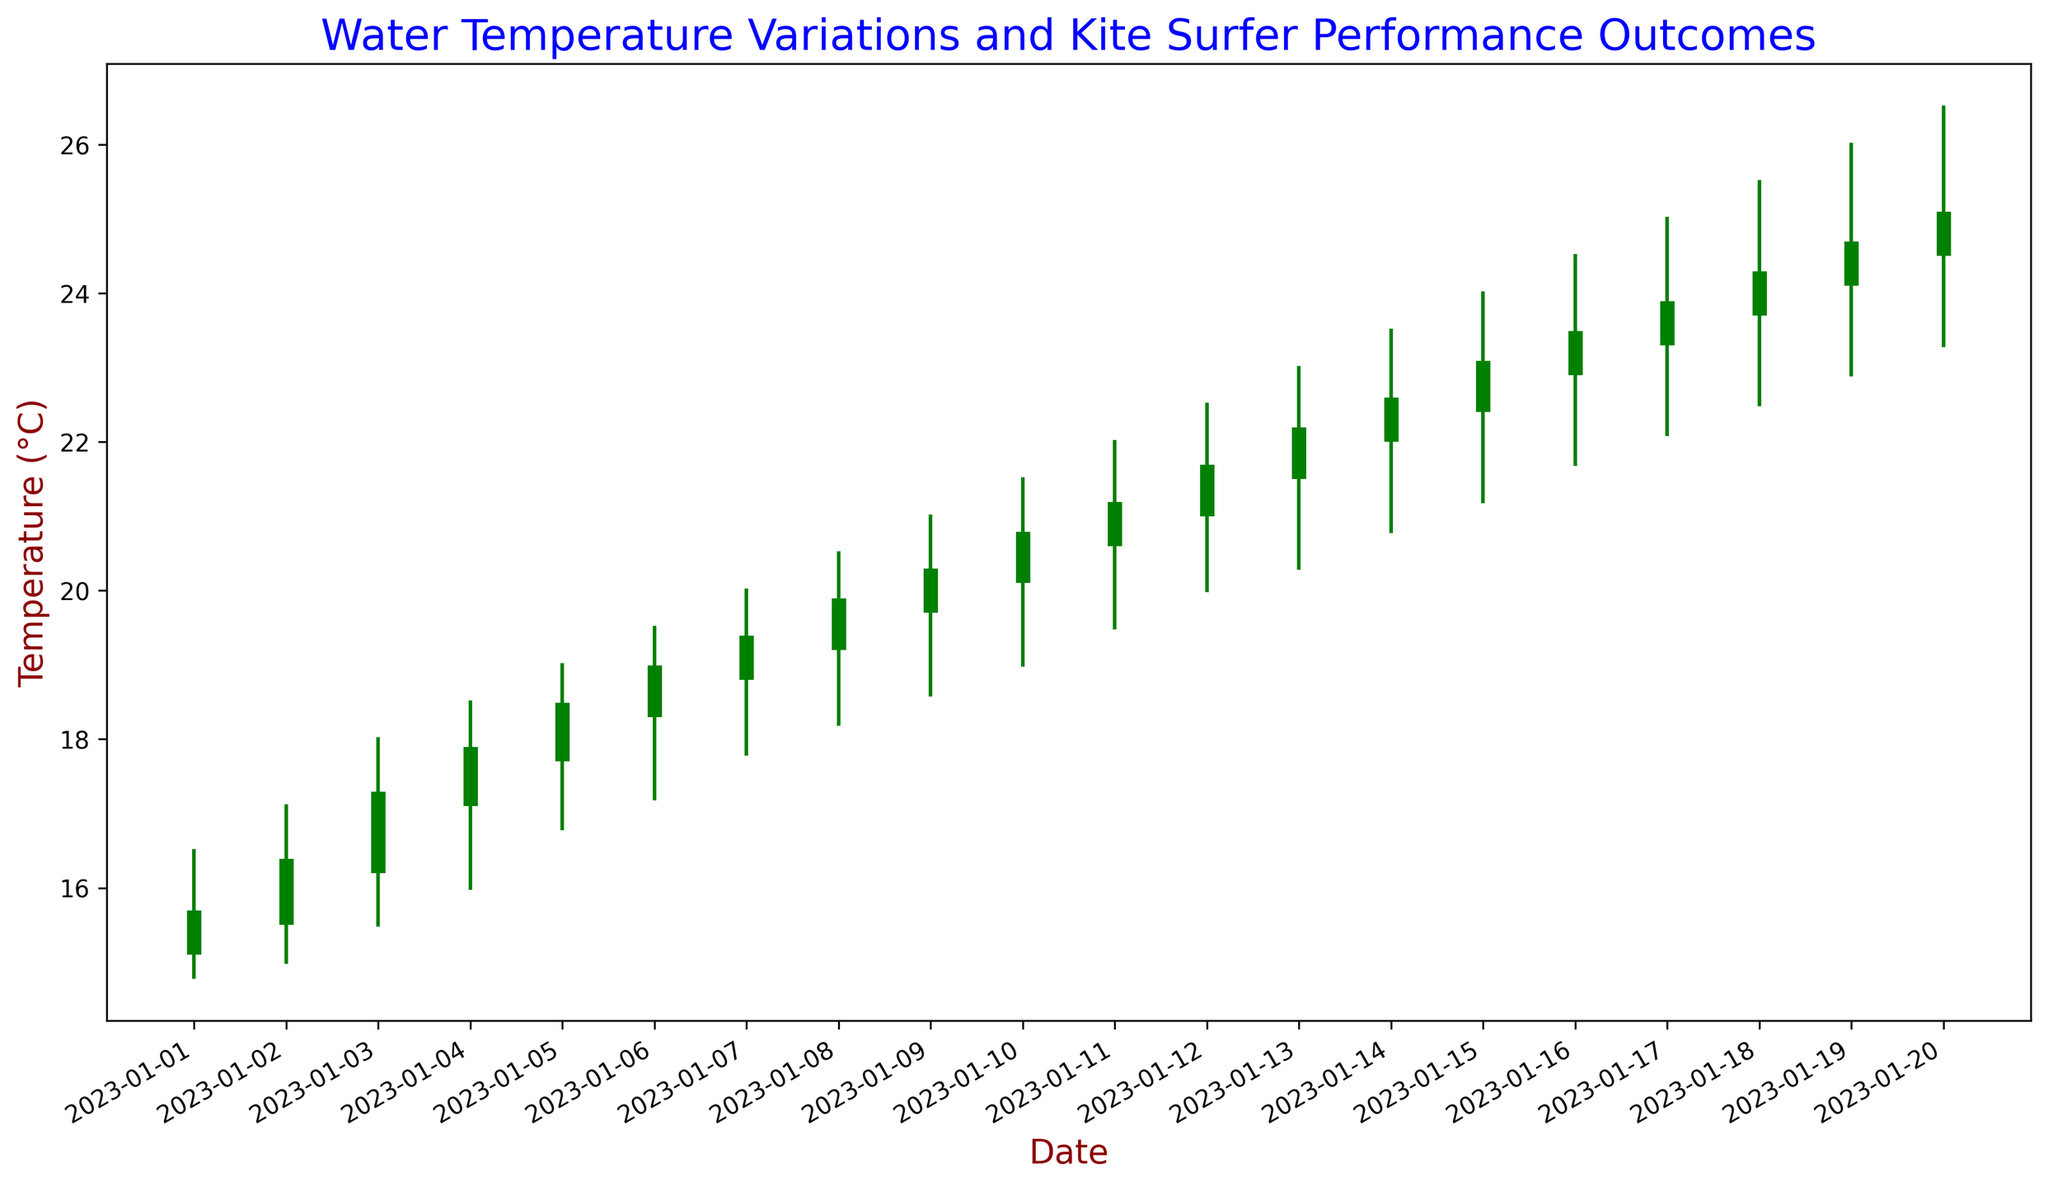What day had the highest recorded water temperature? The graph shows that the highest recorded temperature is on January 20, with a high of 26.5°C.
Answer: January 20 On which days does the close temperature exceed the open temperature? By examining the color of the candlesticks, green indicates the close is higher than the open. The green candlesticks are on January 1, 2, 3, 4, 5, 6, 7, 8, 9, 10, 11, 12, 13, 14, 15, 16, 17, 18, 19, and 20.
Answer: January 1-20 What is the range of water temperatures on January 10? The range on January 10 can be computed by subtracting the low from the high. The high is 21.5°C and the low is 19.0°C, so the range is 21.5 - 19.0 = 2.5°C.
Answer: 2.5°C Which day showed the greatest difference between the high and low temperatures? Examining each bar, the greatest difference is on January 18, where the high is 25.5°C and the low is 22.5°C. The difference is 25.5 - 22.5 = 3.0°C.
Answer: January 18 What is the average close temperature for the first week of January? Adding the close temperatures from January 1 to January 7: 15.6 + 16.3 + 17.2 + 17.8 + 18.4 + 18.9 + 19.3 = 123.5. Dividing by 7 days, 123.5 / 7 = 17.64°C.
Answer: 17.64°C On which days was the closing temperature lower than both the open and high temperatures? Red candlesticks indicate the close is lower than the open. Observing the chart, this situation does not occur as all closing prices are higher than or equal to the opening prices.
Answer: No days Compare the temperature range on January 5 and January 15. Which day had a larger range? January 5 has a high of 19.0°C and a low of 16.8°C, giving a range of 19.0 - 16.8 = 2.2°C. January 15 has a high of 24.0°C and a low of 21.2°C, giving a range of 24.0 - 21.2 = 2.8°C. The larger range is on January 15.
Answer: January 15 